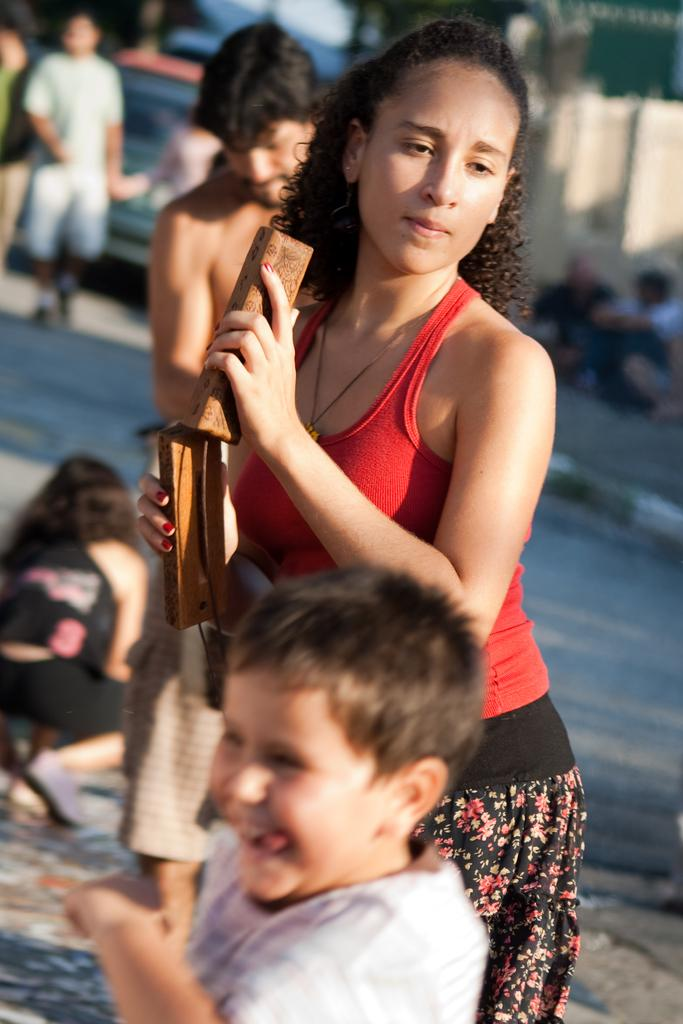How many people are in the image? There is a group of people in the image. What are the people in the image doing? The people are on the ground. Can you describe the woman in the image? There is a woman holding objects in the image. What can be seen in the background of the image? There is a vehicle and unspecified objects in the background of the image. What type of lace is being used to tie the plant in the image? There is no lace or plant present in the image. What type of farming equipment can be seen in the image? There is no farming equipment or farmer present in the image. 